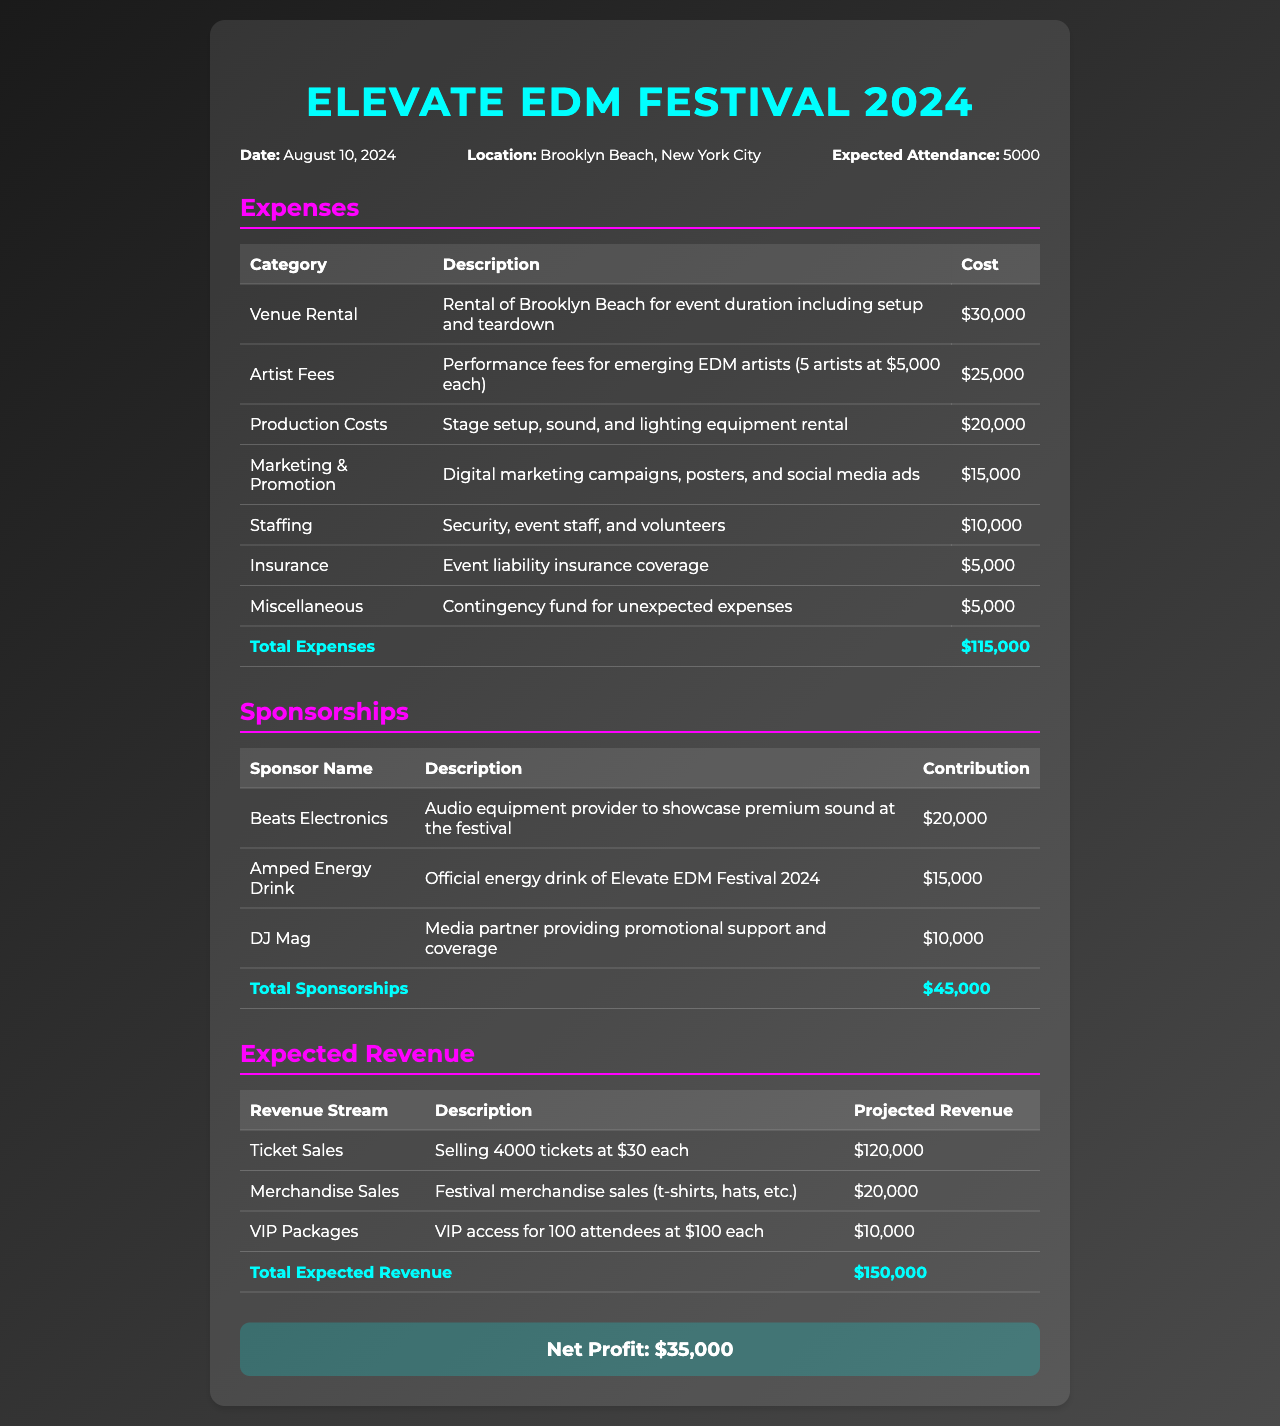what is the date of the Elevate EDM Festival? The document states that the festival is on August 10, 2024.
Answer: August 10, 2024 what is the total estimated attendance for the festival? The expected attendance listed in the document is 5000.
Answer: 5000 how much is allocated for artist fees? The artist fees section specifies a total cost of $25,000 for performance fees.
Answer: $25,000 what is the total amount of sponsorships received? The document indicates that total sponsorships add up to $45,000.
Answer: $45,000 how much is expected from ticket sales? The projected revenue from ticket sales is calculated as selling 4000 tickets at $30 each, which totals $120,000.
Answer: $120,000 what is the cost of insurance for the event? The document specifies that the cost of event liability insurance is $5,000.
Answer: $5,000 how much is the net profit from the festival? The document summarizes the net profit after all expenses and revenues as $35,000.
Answer: $35,000 who is the media partner for the festival? The document identifies DJ Mag as the media partner providing promotional support.
Answer: DJ Mag what are the contributions of Beats Electronics? The document states that Beats Electronics contributes $20,000 as an audio equipment provider.
Answer: $20,000 